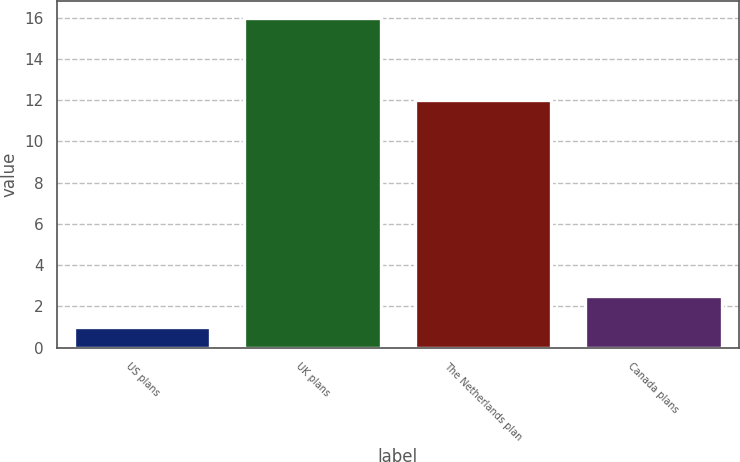<chart> <loc_0><loc_0><loc_500><loc_500><bar_chart><fcel>US plans<fcel>UK plans<fcel>The Netherlands plan<fcel>Canada plans<nl><fcel>1<fcel>16<fcel>12<fcel>2.5<nl></chart> 